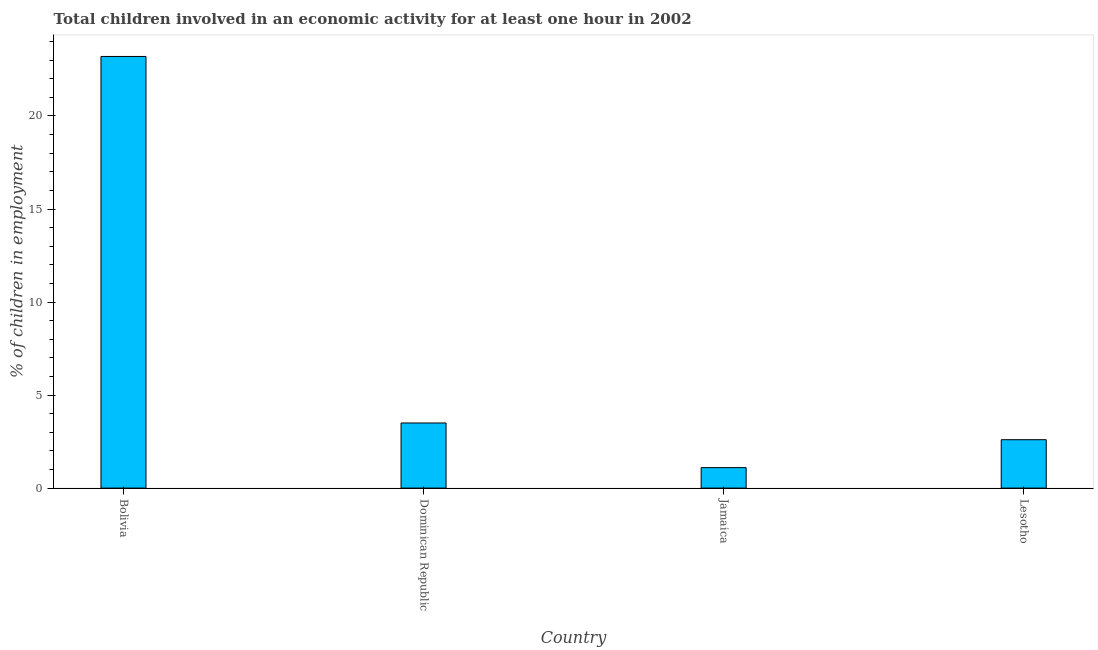Does the graph contain any zero values?
Your answer should be compact. No. Does the graph contain grids?
Offer a very short reply. No. What is the title of the graph?
Your response must be concise. Total children involved in an economic activity for at least one hour in 2002. What is the label or title of the X-axis?
Your response must be concise. Country. What is the label or title of the Y-axis?
Keep it short and to the point. % of children in employment. Across all countries, what is the maximum percentage of children in employment?
Make the answer very short. 23.2. In which country was the percentage of children in employment maximum?
Provide a short and direct response. Bolivia. In which country was the percentage of children in employment minimum?
Your answer should be very brief. Jamaica. What is the sum of the percentage of children in employment?
Ensure brevity in your answer.  30.4. What is the difference between the percentage of children in employment in Bolivia and Dominican Republic?
Provide a succinct answer. 19.7. What is the median percentage of children in employment?
Make the answer very short. 3.05. In how many countries, is the percentage of children in employment greater than 20 %?
Keep it short and to the point. 1. What is the ratio of the percentage of children in employment in Jamaica to that in Lesotho?
Provide a short and direct response. 0.42. What is the difference between the highest and the lowest percentage of children in employment?
Give a very brief answer. 22.1. In how many countries, is the percentage of children in employment greater than the average percentage of children in employment taken over all countries?
Your response must be concise. 1. How many bars are there?
Offer a very short reply. 4. Are the values on the major ticks of Y-axis written in scientific E-notation?
Ensure brevity in your answer.  No. What is the % of children in employment of Bolivia?
Offer a very short reply. 23.2. What is the % of children in employment in Jamaica?
Offer a very short reply. 1.1. What is the difference between the % of children in employment in Bolivia and Jamaica?
Offer a terse response. 22.1. What is the difference between the % of children in employment in Bolivia and Lesotho?
Your response must be concise. 20.6. What is the difference between the % of children in employment in Dominican Republic and Jamaica?
Keep it short and to the point. 2.4. What is the difference between the % of children in employment in Jamaica and Lesotho?
Offer a terse response. -1.5. What is the ratio of the % of children in employment in Bolivia to that in Dominican Republic?
Your answer should be very brief. 6.63. What is the ratio of the % of children in employment in Bolivia to that in Jamaica?
Your answer should be very brief. 21.09. What is the ratio of the % of children in employment in Bolivia to that in Lesotho?
Give a very brief answer. 8.92. What is the ratio of the % of children in employment in Dominican Republic to that in Jamaica?
Provide a short and direct response. 3.18. What is the ratio of the % of children in employment in Dominican Republic to that in Lesotho?
Offer a terse response. 1.35. What is the ratio of the % of children in employment in Jamaica to that in Lesotho?
Provide a succinct answer. 0.42. 